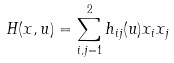Convert formula to latex. <formula><loc_0><loc_0><loc_500><loc_500>H ( x , u ) = \sum _ { i , j = 1 } ^ { 2 } h _ { i j } ( u ) x _ { i } x _ { j }</formula> 